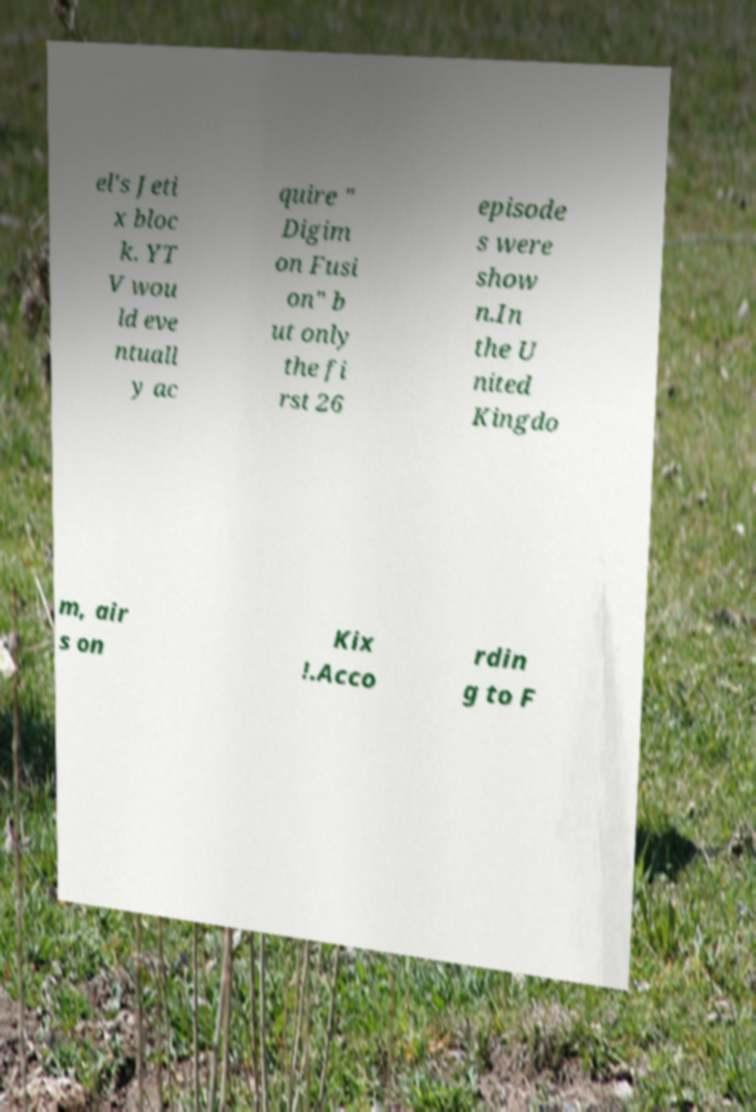Could you extract and type out the text from this image? el's Jeti x bloc k. YT V wou ld eve ntuall y ac quire " Digim on Fusi on" b ut only the fi rst 26 episode s were show n.In the U nited Kingdo m, air s on Kix !.Acco rdin g to F 